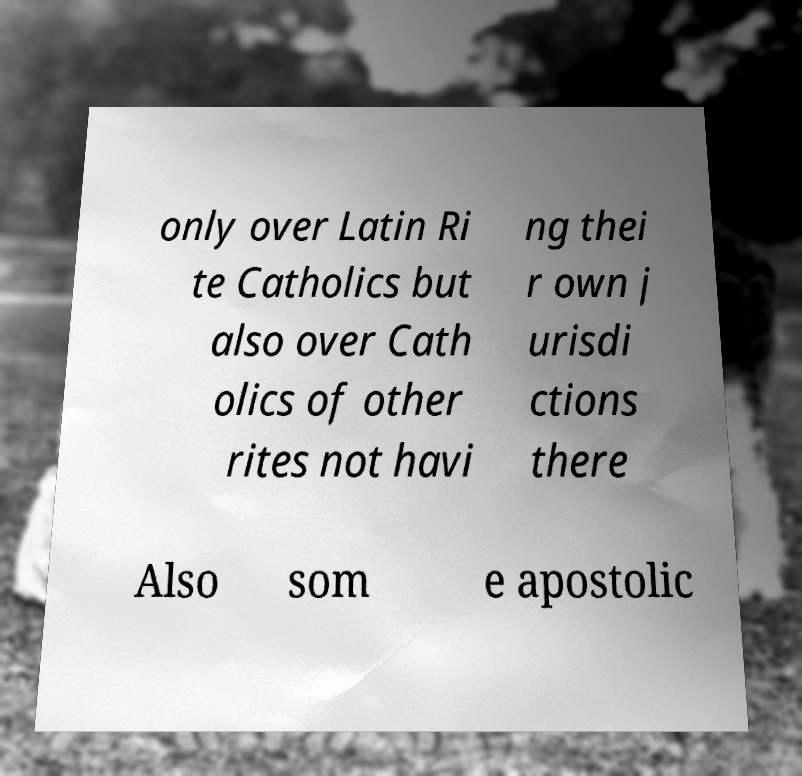For documentation purposes, I need the text within this image transcribed. Could you provide that? only over Latin Ri te Catholics but also over Cath olics of other rites not havi ng thei r own j urisdi ctions there Also som e apostolic 